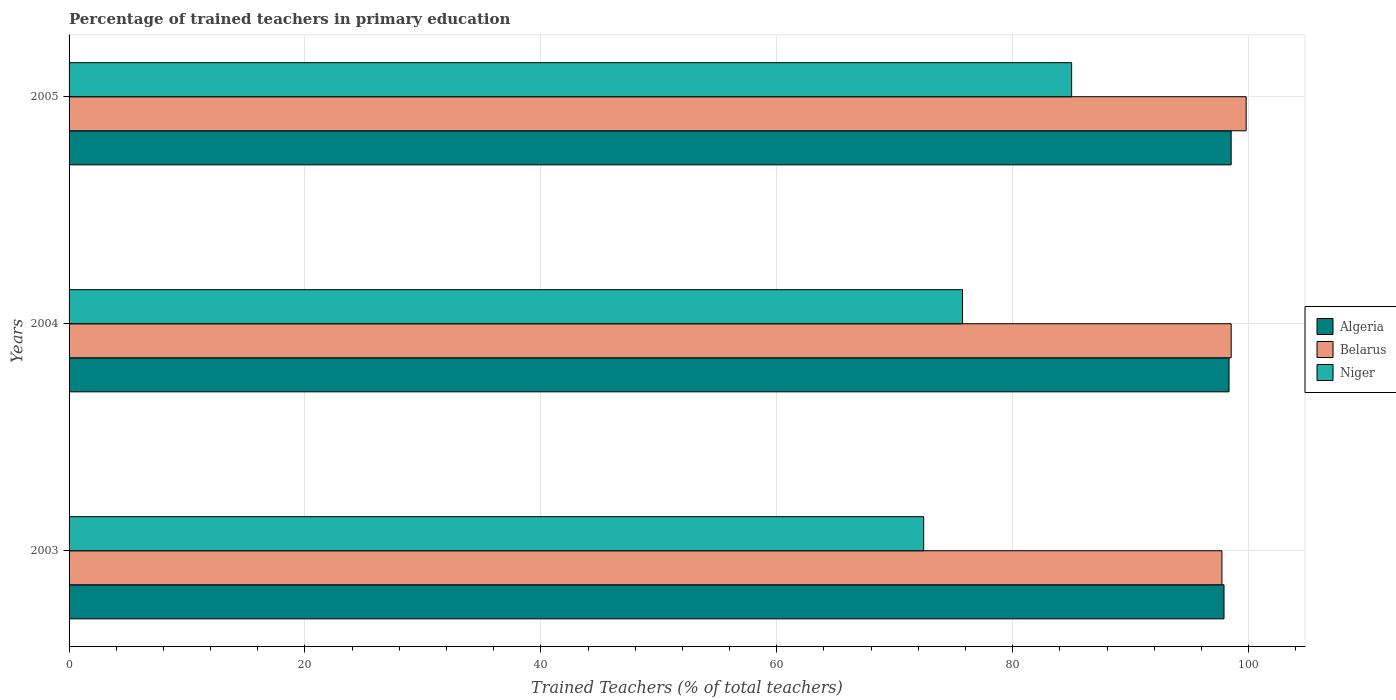How many different coloured bars are there?
Provide a short and direct response. 3. Are the number of bars per tick equal to the number of legend labels?
Make the answer very short. Yes. Are the number of bars on each tick of the Y-axis equal?
Your response must be concise. Yes. What is the label of the 3rd group of bars from the top?
Provide a succinct answer. 2003. What is the percentage of trained teachers in Belarus in 2005?
Provide a short and direct response. 99.8. Across all years, what is the maximum percentage of trained teachers in Niger?
Your response must be concise. 85. Across all years, what is the minimum percentage of trained teachers in Belarus?
Give a very brief answer. 97.74. In which year was the percentage of trained teachers in Algeria maximum?
Provide a succinct answer. 2005. In which year was the percentage of trained teachers in Niger minimum?
Offer a very short reply. 2003. What is the total percentage of trained teachers in Niger in the graph?
Keep it short and to the point. 233.21. What is the difference between the percentage of trained teachers in Belarus in 2004 and that in 2005?
Give a very brief answer. -1.27. What is the difference between the percentage of trained teachers in Niger in 2004 and the percentage of trained teachers in Belarus in 2005?
Provide a succinct answer. -24.05. What is the average percentage of trained teachers in Niger per year?
Your response must be concise. 77.74. In the year 2004, what is the difference between the percentage of trained teachers in Belarus and percentage of trained teachers in Algeria?
Your answer should be very brief. 0.18. What is the ratio of the percentage of trained teachers in Algeria in 2004 to that in 2005?
Give a very brief answer. 1. Is the percentage of trained teachers in Algeria in 2004 less than that in 2005?
Offer a terse response. Yes. Is the difference between the percentage of trained teachers in Belarus in 2004 and 2005 greater than the difference between the percentage of trained teachers in Algeria in 2004 and 2005?
Offer a very short reply. No. What is the difference between the highest and the second highest percentage of trained teachers in Niger?
Keep it short and to the point. 9.25. What is the difference between the highest and the lowest percentage of trained teachers in Niger?
Provide a short and direct response. 12.54. What does the 1st bar from the top in 2005 represents?
Make the answer very short. Niger. What does the 3rd bar from the bottom in 2004 represents?
Your response must be concise. Niger. Is it the case that in every year, the sum of the percentage of trained teachers in Belarus and percentage of trained teachers in Algeria is greater than the percentage of trained teachers in Niger?
Provide a succinct answer. Yes. How many bars are there?
Ensure brevity in your answer.  9. How many years are there in the graph?
Your answer should be very brief. 3. What is the difference between two consecutive major ticks on the X-axis?
Make the answer very short. 20. Are the values on the major ticks of X-axis written in scientific E-notation?
Make the answer very short. No. Does the graph contain any zero values?
Your answer should be very brief. No. Does the graph contain grids?
Provide a succinct answer. Yes. Where does the legend appear in the graph?
Offer a very short reply. Center right. How are the legend labels stacked?
Offer a terse response. Vertical. What is the title of the graph?
Make the answer very short. Percentage of trained teachers in primary education. Does "Tajikistan" appear as one of the legend labels in the graph?
Make the answer very short. No. What is the label or title of the X-axis?
Your response must be concise. Trained Teachers (% of total teachers). What is the Trained Teachers (% of total teachers) of Algeria in 2003?
Keep it short and to the point. 97.92. What is the Trained Teachers (% of total teachers) in Belarus in 2003?
Provide a succinct answer. 97.74. What is the Trained Teachers (% of total teachers) in Niger in 2003?
Offer a terse response. 72.46. What is the Trained Teachers (% of total teachers) in Algeria in 2004?
Offer a very short reply. 98.35. What is the Trained Teachers (% of total teachers) in Belarus in 2004?
Provide a short and direct response. 98.53. What is the Trained Teachers (% of total teachers) in Niger in 2004?
Ensure brevity in your answer.  75.75. What is the Trained Teachers (% of total teachers) in Algeria in 2005?
Your answer should be very brief. 98.53. What is the Trained Teachers (% of total teachers) in Belarus in 2005?
Offer a very short reply. 99.8. What is the Trained Teachers (% of total teachers) in Niger in 2005?
Give a very brief answer. 85. Across all years, what is the maximum Trained Teachers (% of total teachers) in Algeria?
Keep it short and to the point. 98.53. Across all years, what is the maximum Trained Teachers (% of total teachers) of Belarus?
Your answer should be compact. 99.8. Across all years, what is the maximum Trained Teachers (% of total teachers) of Niger?
Give a very brief answer. 85. Across all years, what is the minimum Trained Teachers (% of total teachers) in Algeria?
Make the answer very short. 97.92. Across all years, what is the minimum Trained Teachers (% of total teachers) of Belarus?
Your answer should be very brief. 97.74. Across all years, what is the minimum Trained Teachers (% of total teachers) of Niger?
Make the answer very short. 72.46. What is the total Trained Teachers (% of total teachers) of Algeria in the graph?
Keep it short and to the point. 294.79. What is the total Trained Teachers (% of total teachers) in Belarus in the graph?
Offer a very short reply. 296.07. What is the total Trained Teachers (% of total teachers) in Niger in the graph?
Provide a short and direct response. 233.21. What is the difference between the Trained Teachers (% of total teachers) in Algeria in 2003 and that in 2004?
Give a very brief answer. -0.43. What is the difference between the Trained Teachers (% of total teachers) in Belarus in 2003 and that in 2004?
Make the answer very short. -0.79. What is the difference between the Trained Teachers (% of total teachers) of Niger in 2003 and that in 2004?
Make the answer very short. -3.29. What is the difference between the Trained Teachers (% of total teachers) in Algeria in 2003 and that in 2005?
Provide a succinct answer. -0.61. What is the difference between the Trained Teachers (% of total teachers) of Belarus in 2003 and that in 2005?
Make the answer very short. -2.05. What is the difference between the Trained Teachers (% of total teachers) in Niger in 2003 and that in 2005?
Your response must be concise. -12.54. What is the difference between the Trained Teachers (% of total teachers) of Algeria in 2004 and that in 2005?
Provide a succinct answer. -0.18. What is the difference between the Trained Teachers (% of total teachers) in Belarus in 2004 and that in 2005?
Offer a terse response. -1.27. What is the difference between the Trained Teachers (% of total teachers) in Niger in 2004 and that in 2005?
Your answer should be compact. -9.25. What is the difference between the Trained Teachers (% of total teachers) in Algeria in 2003 and the Trained Teachers (% of total teachers) in Belarus in 2004?
Offer a very short reply. -0.61. What is the difference between the Trained Teachers (% of total teachers) in Algeria in 2003 and the Trained Teachers (% of total teachers) in Niger in 2004?
Your answer should be very brief. 22.17. What is the difference between the Trained Teachers (% of total teachers) of Belarus in 2003 and the Trained Teachers (% of total teachers) of Niger in 2004?
Offer a terse response. 21.99. What is the difference between the Trained Teachers (% of total teachers) of Algeria in 2003 and the Trained Teachers (% of total teachers) of Belarus in 2005?
Ensure brevity in your answer.  -1.88. What is the difference between the Trained Teachers (% of total teachers) of Algeria in 2003 and the Trained Teachers (% of total teachers) of Niger in 2005?
Offer a very short reply. 12.92. What is the difference between the Trained Teachers (% of total teachers) in Belarus in 2003 and the Trained Teachers (% of total teachers) in Niger in 2005?
Your answer should be compact. 12.74. What is the difference between the Trained Teachers (% of total teachers) of Algeria in 2004 and the Trained Teachers (% of total teachers) of Belarus in 2005?
Your answer should be very brief. -1.45. What is the difference between the Trained Teachers (% of total teachers) of Algeria in 2004 and the Trained Teachers (% of total teachers) of Niger in 2005?
Ensure brevity in your answer.  13.34. What is the difference between the Trained Teachers (% of total teachers) in Belarus in 2004 and the Trained Teachers (% of total teachers) in Niger in 2005?
Your answer should be compact. 13.53. What is the average Trained Teachers (% of total teachers) in Algeria per year?
Provide a succinct answer. 98.26. What is the average Trained Teachers (% of total teachers) of Belarus per year?
Ensure brevity in your answer.  98.69. What is the average Trained Teachers (% of total teachers) in Niger per year?
Ensure brevity in your answer.  77.74. In the year 2003, what is the difference between the Trained Teachers (% of total teachers) in Algeria and Trained Teachers (% of total teachers) in Belarus?
Provide a short and direct response. 0.18. In the year 2003, what is the difference between the Trained Teachers (% of total teachers) of Algeria and Trained Teachers (% of total teachers) of Niger?
Offer a terse response. 25.46. In the year 2003, what is the difference between the Trained Teachers (% of total teachers) in Belarus and Trained Teachers (% of total teachers) in Niger?
Offer a very short reply. 25.29. In the year 2004, what is the difference between the Trained Teachers (% of total teachers) of Algeria and Trained Teachers (% of total teachers) of Belarus?
Ensure brevity in your answer.  -0.18. In the year 2004, what is the difference between the Trained Teachers (% of total teachers) in Algeria and Trained Teachers (% of total teachers) in Niger?
Keep it short and to the point. 22.6. In the year 2004, what is the difference between the Trained Teachers (% of total teachers) of Belarus and Trained Teachers (% of total teachers) of Niger?
Make the answer very short. 22.78. In the year 2005, what is the difference between the Trained Teachers (% of total teachers) in Algeria and Trained Teachers (% of total teachers) in Belarus?
Make the answer very short. -1.27. In the year 2005, what is the difference between the Trained Teachers (% of total teachers) in Algeria and Trained Teachers (% of total teachers) in Niger?
Keep it short and to the point. 13.53. In the year 2005, what is the difference between the Trained Teachers (% of total teachers) in Belarus and Trained Teachers (% of total teachers) in Niger?
Your response must be concise. 14.8. What is the ratio of the Trained Teachers (% of total teachers) of Niger in 2003 to that in 2004?
Offer a very short reply. 0.96. What is the ratio of the Trained Teachers (% of total teachers) of Belarus in 2003 to that in 2005?
Your response must be concise. 0.98. What is the ratio of the Trained Teachers (% of total teachers) of Niger in 2003 to that in 2005?
Offer a very short reply. 0.85. What is the ratio of the Trained Teachers (% of total teachers) of Belarus in 2004 to that in 2005?
Make the answer very short. 0.99. What is the ratio of the Trained Teachers (% of total teachers) of Niger in 2004 to that in 2005?
Make the answer very short. 0.89. What is the difference between the highest and the second highest Trained Teachers (% of total teachers) in Algeria?
Offer a terse response. 0.18. What is the difference between the highest and the second highest Trained Teachers (% of total teachers) in Belarus?
Provide a succinct answer. 1.27. What is the difference between the highest and the second highest Trained Teachers (% of total teachers) in Niger?
Provide a succinct answer. 9.25. What is the difference between the highest and the lowest Trained Teachers (% of total teachers) of Algeria?
Give a very brief answer. 0.61. What is the difference between the highest and the lowest Trained Teachers (% of total teachers) of Belarus?
Provide a short and direct response. 2.05. What is the difference between the highest and the lowest Trained Teachers (% of total teachers) in Niger?
Your answer should be compact. 12.54. 